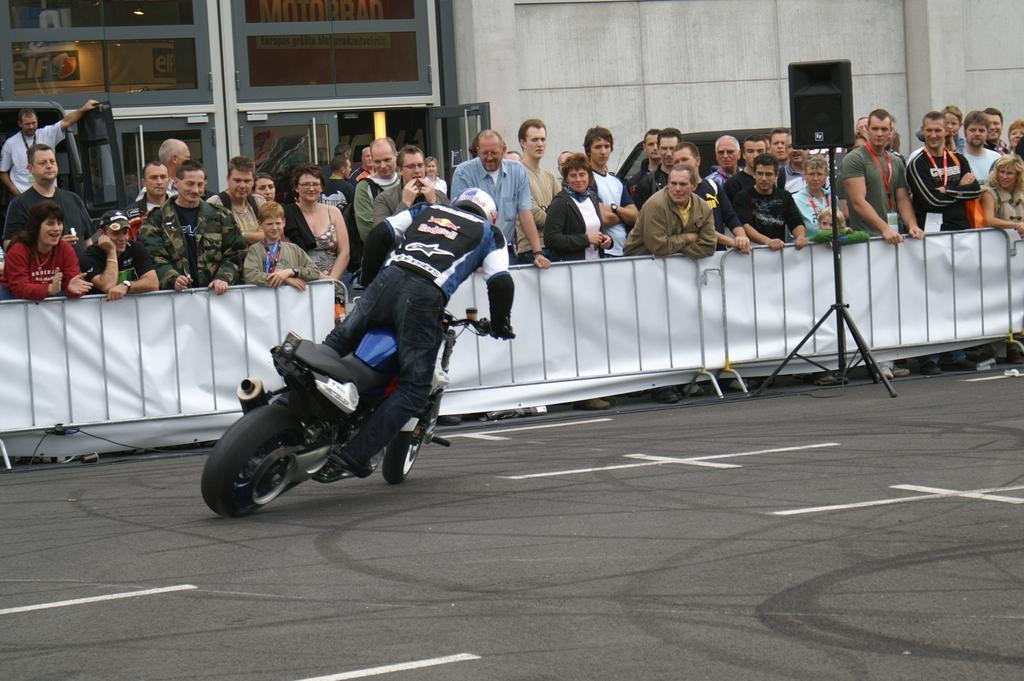Describe this image in one or two sentences. In this picture we can see a man riding bike on road and aside to this road we have a fence, stand with speakers and a group of people standing and looking at him and in the background we can see wall, door, vehicle, banner. 